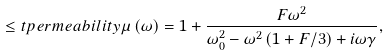Convert formula to latex. <formula><loc_0><loc_0><loc_500><loc_500>\leq t { p e r m e a b i l i t y } \mu \left ( \omega \right ) = 1 + \frac { F \omega ^ { 2 } } { \omega _ { 0 } ^ { 2 } - \omega ^ { 2 } \left ( 1 + F / 3 \right ) + i \omega \gamma } ,</formula> 